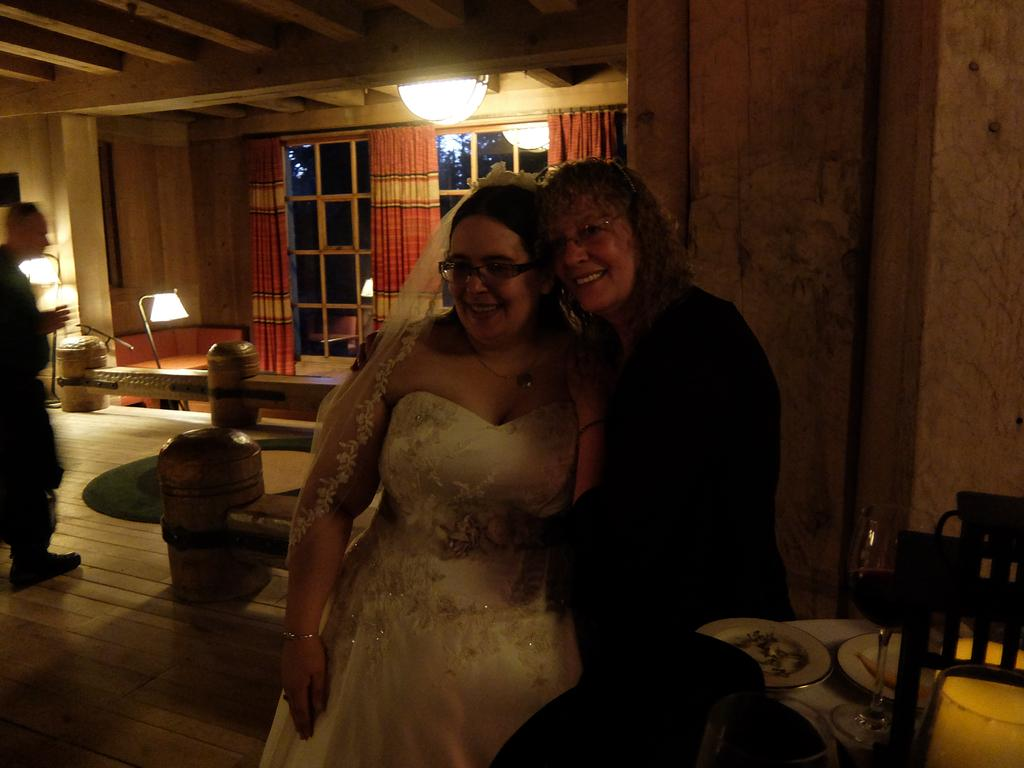How many people are in the image? There are two women in the image. What are the women doing in the image? The women are standing. Can you describe the lighting in the room? The room appears to be a little dark. What type of beetle can be seen crawling on the floor in the image? There is no beetle present in the image. How does the room measure in terms of square footage? The provided facts do not give any information about the size of the room, so it cannot be determined from the image. 